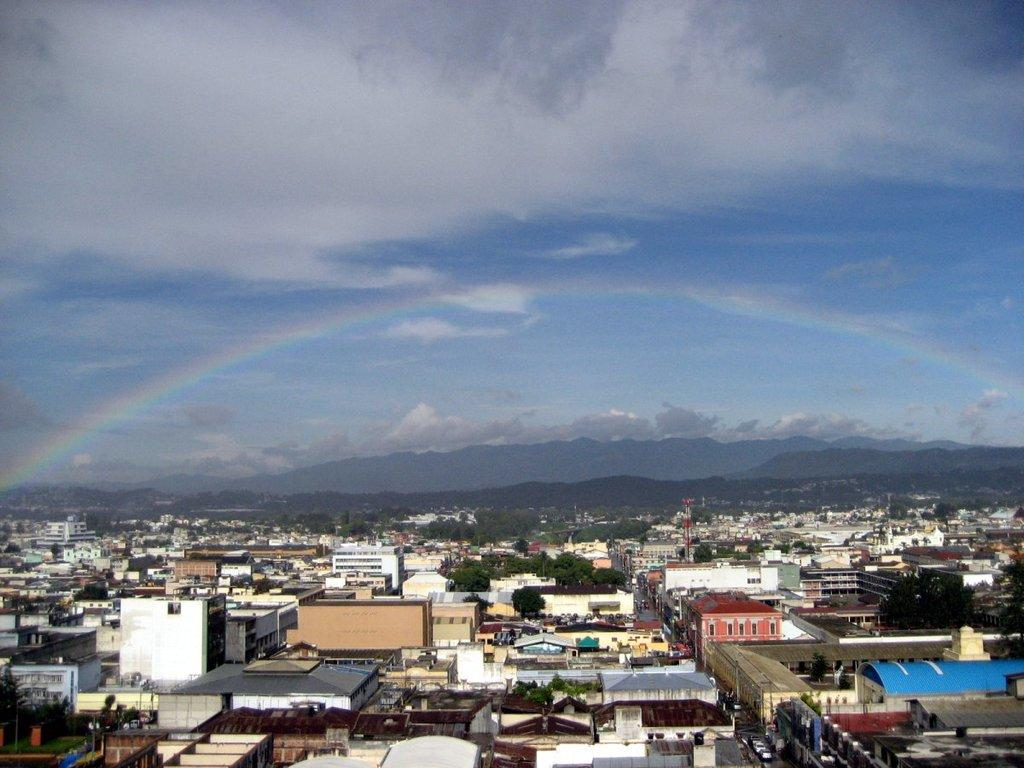What type of structures can be seen in the image? There are buildings in the image. What type of vegetation is present in the image? There are trees with green color in the image. What natural phenomenon can be seen in the background of the image? There is a rainbow visible in the background of the image. What colors are present in the sky in the image? The sky is in white and blue color. Where is the station located in the image? There is no station present in the image. What type of brush is used by the maid in the image? There is no maid or brush present in the image. 